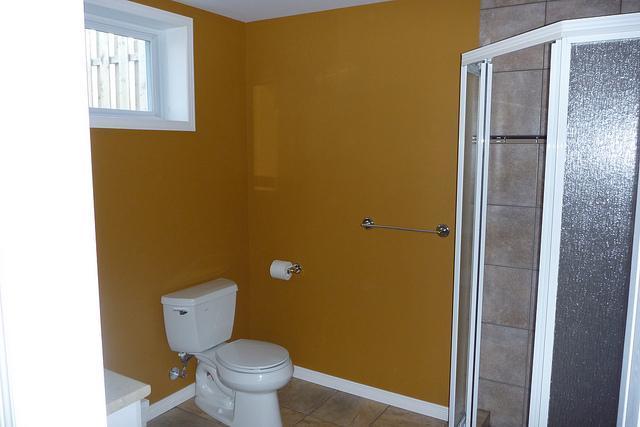How many towel racks are in the room?
Give a very brief answer. 1. 